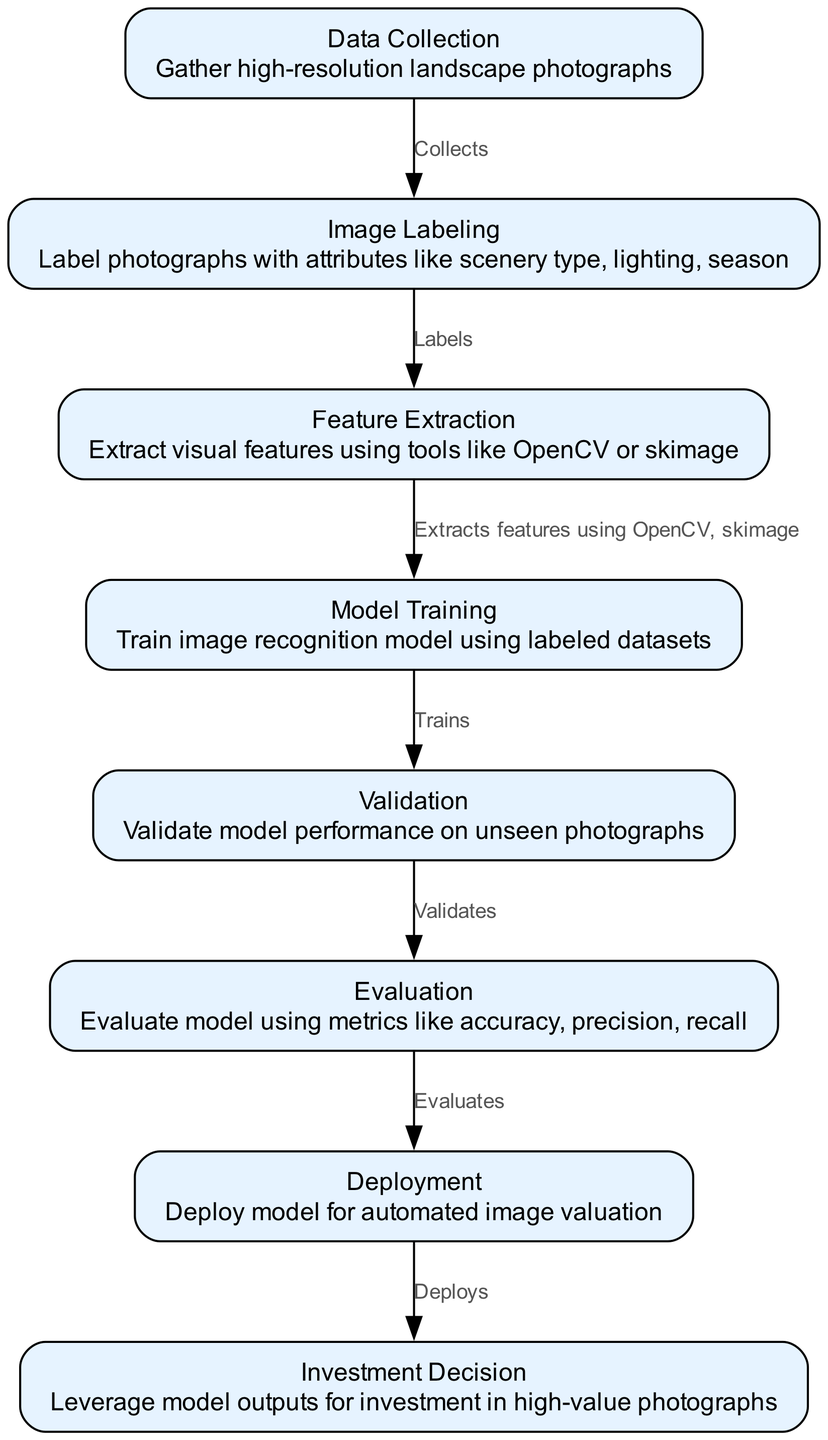What is the first node in the diagram? The first node is "Data Collection," which is where high-resolution landscape photographs are gathered.
Answer: Data Collection How many nodes are present in the diagram? By counting the individual nodes listed in the diagram, we find there are eight nodes total, including all stages of the process.
Answer: Eight What does the image labeling node do? The image labeling node assigns labels to photographs indicating various attributes such as scenery type and season.
Answer: Label photographs with attributes What is the connection between feature extraction and model training? Feature extraction provides the necessary visual features to the model training node, which uses these features alongside the labeled data to train the image recognition model.
Answer: Extracts features using OpenCV, skimage Which node comes after validation? The evaluation node directly follows the validation stage, as it measures the performance of the model that was validated.
Answer: Evaluation What is the main outcome of the deployment stage? The deployment stage produces the final output of the model, making it available for automated valuation of images.
Answer: Deploys model for automated image valuation Explain why the investment decision relies on model outputs. The investment decision is based on insights derived from the model outputs, which evaluate high-value photographs and guide purchasing choices.
Answer: Leverage model outputs for investment What type of edge connects image labeling to feature extraction? The edge that connects these two nodes is labeled "Labels," indicating that the image labeling process supplies labeled data to feature extraction.
Answer: Labels What evaluation metrics are used in the evaluation node? The evaluation node employs metrics such as accuracy, precision, and recall to assess the model's effectiveness.
Answer: Accuracy, precision, recall 